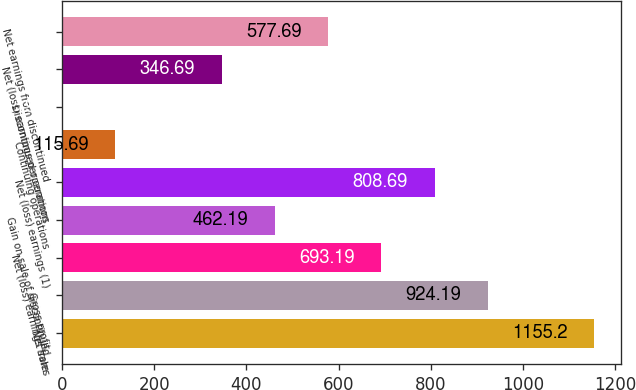<chart> <loc_0><loc_0><loc_500><loc_500><bar_chart><fcel>Net sales<fcel>Gross profit<fcel>Net (loss) earnings from<fcel>Gain on sale of discontinued<fcel>Net (loss) earnings (1)<fcel>Continuing operations<fcel>Discontinued operations<fcel>Net (loss) earnings per common<fcel>Net earnings from discontinued<nl><fcel>1155.2<fcel>924.19<fcel>693.19<fcel>462.19<fcel>808.69<fcel>115.69<fcel>0.19<fcel>346.69<fcel>577.69<nl></chart> 